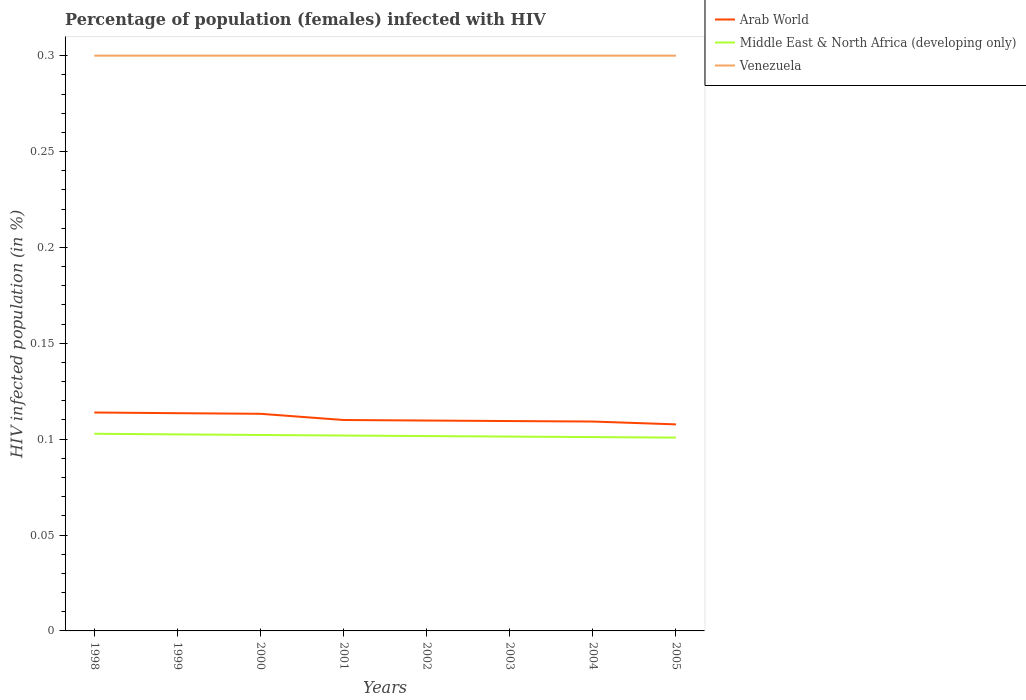How many different coloured lines are there?
Provide a succinct answer. 3. Does the line corresponding to Venezuela intersect with the line corresponding to Arab World?
Ensure brevity in your answer.  No. Across all years, what is the maximum percentage of HIV infected female population in Arab World?
Provide a succinct answer. 0.11. What is the total percentage of HIV infected female population in Arab World in the graph?
Your response must be concise. 0. What is the difference between the highest and the second highest percentage of HIV infected female population in Middle East & North Africa (developing only)?
Your answer should be very brief. 0. Is the percentage of HIV infected female population in Venezuela strictly greater than the percentage of HIV infected female population in Arab World over the years?
Offer a very short reply. No. How many years are there in the graph?
Give a very brief answer. 8. Does the graph contain any zero values?
Ensure brevity in your answer.  No. Where does the legend appear in the graph?
Offer a terse response. Top right. How many legend labels are there?
Your answer should be very brief. 3. How are the legend labels stacked?
Keep it short and to the point. Vertical. What is the title of the graph?
Give a very brief answer. Percentage of population (females) infected with HIV. What is the label or title of the Y-axis?
Your response must be concise. HIV infected population (in %). What is the HIV infected population (in %) of Arab World in 1998?
Ensure brevity in your answer.  0.11. What is the HIV infected population (in %) in Middle East & North Africa (developing only) in 1998?
Keep it short and to the point. 0.1. What is the HIV infected population (in %) of Venezuela in 1998?
Ensure brevity in your answer.  0.3. What is the HIV infected population (in %) in Arab World in 1999?
Your answer should be compact. 0.11. What is the HIV infected population (in %) in Middle East & North Africa (developing only) in 1999?
Your answer should be very brief. 0.1. What is the HIV infected population (in %) of Arab World in 2000?
Your answer should be compact. 0.11. What is the HIV infected population (in %) in Middle East & North Africa (developing only) in 2000?
Ensure brevity in your answer.  0.1. What is the HIV infected population (in %) of Venezuela in 2000?
Provide a succinct answer. 0.3. What is the HIV infected population (in %) of Arab World in 2001?
Your answer should be compact. 0.11. What is the HIV infected population (in %) in Middle East & North Africa (developing only) in 2001?
Offer a terse response. 0.1. What is the HIV infected population (in %) in Venezuela in 2001?
Give a very brief answer. 0.3. What is the HIV infected population (in %) of Arab World in 2002?
Ensure brevity in your answer.  0.11. What is the HIV infected population (in %) of Middle East & North Africa (developing only) in 2002?
Offer a very short reply. 0.1. What is the HIV infected population (in %) in Arab World in 2003?
Make the answer very short. 0.11. What is the HIV infected population (in %) in Middle East & North Africa (developing only) in 2003?
Make the answer very short. 0.1. What is the HIV infected population (in %) in Venezuela in 2003?
Your response must be concise. 0.3. What is the HIV infected population (in %) of Arab World in 2004?
Provide a short and direct response. 0.11. What is the HIV infected population (in %) of Middle East & North Africa (developing only) in 2004?
Offer a terse response. 0.1. What is the HIV infected population (in %) in Arab World in 2005?
Provide a short and direct response. 0.11. What is the HIV infected population (in %) of Middle East & North Africa (developing only) in 2005?
Offer a terse response. 0.1. Across all years, what is the maximum HIV infected population (in %) of Arab World?
Offer a terse response. 0.11. Across all years, what is the maximum HIV infected population (in %) in Middle East & North Africa (developing only)?
Your answer should be very brief. 0.1. Across all years, what is the maximum HIV infected population (in %) in Venezuela?
Keep it short and to the point. 0.3. Across all years, what is the minimum HIV infected population (in %) in Arab World?
Provide a short and direct response. 0.11. Across all years, what is the minimum HIV infected population (in %) in Middle East & North Africa (developing only)?
Your answer should be compact. 0.1. What is the total HIV infected population (in %) of Arab World in the graph?
Your answer should be very brief. 0.89. What is the total HIV infected population (in %) of Middle East & North Africa (developing only) in the graph?
Your answer should be very brief. 0.81. What is the difference between the HIV infected population (in %) of Middle East & North Africa (developing only) in 1998 and that in 1999?
Your response must be concise. 0. What is the difference between the HIV infected population (in %) in Venezuela in 1998 and that in 1999?
Offer a very short reply. 0. What is the difference between the HIV infected population (in %) of Arab World in 1998 and that in 2000?
Offer a terse response. 0. What is the difference between the HIV infected population (in %) of Middle East & North Africa (developing only) in 1998 and that in 2000?
Ensure brevity in your answer.  0. What is the difference between the HIV infected population (in %) of Venezuela in 1998 and that in 2000?
Your answer should be very brief. 0. What is the difference between the HIV infected population (in %) of Arab World in 1998 and that in 2001?
Offer a terse response. 0. What is the difference between the HIV infected population (in %) of Middle East & North Africa (developing only) in 1998 and that in 2001?
Ensure brevity in your answer.  0. What is the difference between the HIV infected population (in %) of Venezuela in 1998 and that in 2001?
Your response must be concise. 0. What is the difference between the HIV infected population (in %) in Arab World in 1998 and that in 2002?
Your response must be concise. 0. What is the difference between the HIV infected population (in %) of Middle East & North Africa (developing only) in 1998 and that in 2002?
Give a very brief answer. 0. What is the difference between the HIV infected population (in %) in Arab World in 1998 and that in 2003?
Your response must be concise. 0. What is the difference between the HIV infected population (in %) in Middle East & North Africa (developing only) in 1998 and that in 2003?
Offer a very short reply. 0. What is the difference between the HIV infected population (in %) in Arab World in 1998 and that in 2004?
Provide a short and direct response. 0. What is the difference between the HIV infected population (in %) of Middle East & North Africa (developing only) in 1998 and that in 2004?
Your answer should be very brief. 0. What is the difference between the HIV infected population (in %) in Venezuela in 1998 and that in 2004?
Provide a succinct answer. 0. What is the difference between the HIV infected population (in %) in Arab World in 1998 and that in 2005?
Provide a succinct answer. 0.01. What is the difference between the HIV infected population (in %) of Middle East & North Africa (developing only) in 1998 and that in 2005?
Your answer should be very brief. 0. What is the difference between the HIV infected population (in %) in Arab World in 1999 and that in 2000?
Make the answer very short. 0. What is the difference between the HIV infected population (in %) of Middle East & North Africa (developing only) in 1999 and that in 2000?
Offer a terse response. 0. What is the difference between the HIV infected population (in %) in Arab World in 1999 and that in 2001?
Offer a terse response. 0. What is the difference between the HIV infected population (in %) of Middle East & North Africa (developing only) in 1999 and that in 2001?
Your answer should be compact. 0. What is the difference between the HIV infected population (in %) of Arab World in 1999 and that in 2002?
Offer a terse response. 0. What is the difference between the HIV infected population (in %) of Middle East & North Africa (developing only) in 1999 and that in 2002?
Keep it short and to the point. 0. What is the difference between the HIV infected population (in %) of Arab World in 1999 and that in 2003?
Provide a short and direct response. 0. What is the difference between the HIV infected population (in %) in Middle East & North Africa (developing only) in 1999 and that in 2003?
Provide a short and direct response. 0. What is the difference between the HIV infected population (in %) of Venezuela in 1999 and that in 2003?
Your response must be concise. 0. What is the difference between the HIV infected population (in %) in Arab World in 1999 and that in 2004?
Give a very brief answer. 0. What is the difference between the HIV infected population (in %) of Middle East & North Africa (developing only) in 1999 and that in 2004?
Ensure brevity in your answer.  0. What is the difference between the HIV infected population (in %) in Venezuela in 1999 and that in 2004?
Ensure brevity in your answer.  0. What is the difference between the HIV infected population (in %) in Arab World in 1999 and that in 2005?
Your answer should be compact. 0.01. What is the difference between the HIV infected population (in %) of Middle East & North Africa (developing only) in 1999 and that in 2005?
Make the answer very short. 0. What is the difference between the HIV infected population (in %) of Venezuela in 1999 and that in 2005?
Your answer should be very brief. 0. What is the difference between the HIV infected population (in %) in Arab World in 2000 and that in 2001?
Make the answer very short. 0. What is the difference between the HIV infected population (in %) of Middle East & North Africa (developing only) in 2000 and that in 2001?
Provide a short and direct response. 0. What is the difference between the HIV infected population (in %) in Venezuela in 2000 and that in 2001?
Ensure brevity in your answer.  0. What is the difference between the HIV infected population (in %) in Arab World in 2000 and that in 2002?
Give a very brief answer. 0. What is the difference between the HIV infected population (in %) in Middle East & North Africa (developing only) in 2000 and that in 2002?
Offer a very short reply. 0. What is the difference between the HIV infected population (in %) in Venezuela in 2000 and that in 2002?
Your response must be concise. 0. What is the difference between the HIV infected population (in %) of Arab World in 2000 and that in 2003?
Give a very brief answer. 0. What is the difference between the HIV infected population (in %) in Middle East & North Africa (developing only) in 2000 and that in 2003?
Offer a very short reply. 0. What is the difference between the HIV infected population (in %) in Venezuela in 2000 and that in 2003?
Offer a very short reply. 0. What is the difference between the HIV infected population (in %) in Arab World in 2000 and that in 2004?
Your answer should be very brief. 0. What is the difference between the HIV infected population (in %) of Middle East & North Africa (developing only) in 2000 and that in 2004?
Offer a terse response. 0. What is the difference between the HIV infected population (in %) in Venezuela in 2000 and that in 2004?
Offer a very short reply. 0. What is the difference between the HIV infected population (in %) in Arab World in 2000 and that in 2005?
Your response must be concise. 0.01. What is the difference between the HIV infected population (in %) of Middle East & North Africa (developing only) in 2000 and that in 2005?
Keep it short and to the point. 0. What is the difference between the HIV infected population (in %) of Venezuela in 2000 and that in 2005?
Offer a very short reply. 0. What is the difference between the HIV infected population (in %) in Arab World in 2001 and that in 2002?
Provide a succinct answer. 0. What is the difference between the HIV infected population (in %) of Arab World in 2001 and that in 2004?
Give a very brief answer. 0. What is the difference between the HIV infected population (in %) in Middle East & North Africa (developing only) in 2001 and that in 2004?
Keep it short and to the point. 0. What is the difference between the HIV infected population (in %) in Arab World in 2001 and that in 2005?
Offer a very short reply. 0. What is the difference between the HIV infected population (in %) in Middle East & North Africa (developing only) in 2001 and that in 2005?
Make the answer very short. 0. What is the difference between the HIV infected population (in %) in Arab World in 2002 and that in 2003?
Provide a succinct answer. 0. What is the difference between the HIV infected population (in %) of Venezuela in 2002 and that in 2003?
Your answer should be compact. 0. What is the difference between the HIV infected population (in %) in Arab World in 2002 and that in 2004?
Your answer should be compact. 0. What is the difference between the HIV infected population (in %) of Arab World in 2002 and that in 2005?
Offer a terse response. 0. What is the difference between the HIV infected population (in %) in Middle East & North Africa (developing only) in 2002 and that in 2005?
Provide a short and direct response. 0. What is the difference between the HIV infected population (in %) in Arab World in 2003 and that in 2004?
Offer a very short reply. 0. What is the difference between the HIV infected population (in %) in Middle East & North Africa (developing only) in 2003 and that in 2004?
Keep it short and to the point. 0. What is the difference between the HIV infected population (in %) in Arab World in 2003 and that in 2005?
Keep it short and to the point. 0. What is the difference between the HIV infected population (in %) of Middle East & North Africa (developing only) in 2003 and that in 2005?
Your answer should be very brief. 0. What is the difference between the HIV infected population (in %) of Venezuela in 2003 and that in 2005?
Your answer should be very brief. 0. What is the difference between the HIV infected population (in %) in Arab World in 2004 and that in 2005?
Offer a terse response. 0. What is the difference between the HIV infected population (in %) in Venezuela in 2004 and that in 2005?
Your response must be concise. 0. What is the difference between the HIV infected population (in %) in Arab World in 1998 and the HIV infected population (in %) in Middle East & North Africa (developing only) in 1999?
Ensure brevity in your answer.  0.01. What is the difference between the HIV infected population (in %) of Arab World in 1998 and the HIV infected population (in %) of Venezuela in 1999?
Your answer should be very brief. -0.19. What is the difference between the HIV infected population (in %) of Middle East & North Africa (developing only) in 1998 and the HIV infected population (in %) of Venezuela in 1999?
Your answer should be compact. -0.2. What is the difference between the HIV infected population (in %) in Arab World in 1998 and the HIV infected population (in %) in Middle East & North Africa (developing only) in 2000?
Give a very brief answer. 0.01. What is the difference between the HIV infected population (in %) in Arab World in 1998 and the HIV infected population (in %) in Venezuela in 2000?
Provide a short and direct response. -0.19. What is the difference between the HIV infected population (in %) in Middle East & North Africa (developing only) in 1998 and the HIV infected population (in %) in Venezuela in 2000?
Provide a succinct answer. -0.2. What is the difference between the HIV infected population (in %) of Arab World in 1998 and the HIV infected population (in %) of Middle East & North Africa (developing only) in 2001?
Your answer should be very brief. 0.01. What is the difference between the HIV infected population (in %) in Arab World in 1998 and the HIV infected population (in %) in Venezuela in 2001?
Make the answer very short. -0.19. What is the difference between the HIV infected population (in %) in Middle East & North Africa (developing only) in 1998 and the HIV infected population (in %) in Venezuela in 2001?
Offer a terse response. -0.2. What is the difference between the HIV infected population (in %) of Arab World in 1998 and the HIV infected population (in %) of Middle East & North Africa (developing only) in 2002?
Keep it short and to the point. 0.01. What is the difference between the HIV infected population (in %) of Arab World in 1998 and the HIV infected population (in %) of Venezuela in 2002?
Offer a terse response. -0.19. What is the difference between the HIV infected population (in %) in Middle East & North Africa (developing only) in 1998 and the HIV infected population (in %) in Venezuela in 2002?
Provide a short and direct response. -0.2. What is the difference between the HIV infected population (in %) in Arab World in 1998 and the HIV infected population (in %) in Middle East & North Africa (developing only) in 2003?
Provide a succinct answer. 0.01. What is the difference between the HIV infected population (in %) in Arab World in 1998 and the HIV infected population (in %) in Venezuela in 2003?
Your answer should be very brief. -0.19. What is the difference between the HIV infected population (in %) of Middle East & North Africa (developing only) in 1998 and the HIV infected population (in %) of Venezuela in 2003?
Your answer should be compact. -0.2. What is the difference between the HIV infected population (in %) of Arab World in 1998 and the HIV infected population (in %) of Middle East & North Africa (developing only) in 2004?
Make the answer very short. 0.01. What is the difference between the HIV infected population (in %) of Arab World in 1998 and the HIV infected population (in %) of Venezuela in 2004?
Your answer should be compact. -0.19. What is the difference between the HIV infected population (in %) in Middle East & North Africa (developing only) in 1998 and the HIV infected population (in %) in Venezuela in 2004?
Provide a short and direct response. -0.2. What is the difference between the HIV infected population (in %) in Arab World in 1998 and the HIV infected population (in %) in Middle East & North Africa (developing only) in 2005?
Make the answer very short. 0.01. What is the difference between the HIV infected population (in %) of Arab World in 1998 and the HIV infected population (in %) of Venezuela in 2005?
Give a very brief answer. -0.19. What is the difference between the HIV infected population (in %) of Middle East & North Africa (developing only) in 1998 and the HIV infected population (in %) of Venezuela in 2005?
Ensure brevity in your answer.  -0.2. What is the difference between the HIV infected population (in %) of Arab World in 1999 and the HIV infected population (in %) of Middle East & North Africa (developing only) in 2000?
Your answer should be very brief. 0.01. What is the difference between the HIV infected population (in %) of Arab World in 1999 and the HIV infected population (in %) of Venezuela in 2000?
Your response must be concise. -0.19. What is the difference between the HIV infected population (in %) of Middle East & North Africa (developing only) in 1999 and the HIV infected population (in %) of Venezuela in 2000?
Your response must be concise. -0.2. What is the difference between the HIV infected population (in %) in Arab World in 1999 and the HIV infected population (in %) in Middle East & North Africa (developing only) in 2001?
Give a very brief answer. 0.01. What is the difference between the HIV infected population (in %) in Arab World in 1999 and the HIV infected population (in %) in Venezuela in 2001?
Your answer should be very brief. -0.19. What is the difference between the HIV infected population (in %) in Middle East & North Africa (developing only) in 1999 and the HIV infected population (in %) in Venezuela in 2001?
Ensure brevity in your answer.  -0.2. What is the difference between the HIV infected population (in %) in Arab World in 1999 and the HIV infected population (in %) in Middle East & North Africa (developing only) in 2002?
Your response must be concise. 0.01. What is the difference between the HIV infected population (in %) in Arab World in 1999 and the HIV infected population (in %) in Venezuela in 2002?
Your answer should be very brief. -0.19. What is the difference between the HIV infected population (in %) in Middle East & North Africa (developing only) in 1999 and the HIV infected population (in %) in Venezuela in 2002?
Give a very brief answer. -0.2. What is the difference between the HIV infected population (in %) of Arab World in 1999 and the HIV infected population (in %) of Middle East & North Africa (developing only) in 2003?
Your response must be concise. 0.01. What is the difference between the HIV infected population (in %) in Arab World in 1999 and the HIV infected population (in %) in Venezuela in 2003?
Provide a short and direct response. -0.19. What is the difference between the HIV infected population (in %) of Middle East & North Africa (developing only) in 1999 and the HIV infected population (in %) of Venezuela in 2003?
Your answer should be compact. -0.2. What is the difference between the HIV infected population (in %) in Arab World in 1999 and the HIV infected population (in %) in Middle East & North Africa (developing only) in 2004?
Your answer should be very brief. 0.01. What is the difference between the HIV infected population (in %) in Arab World in 1999 and the HIV infected population (in %) in Venezuela in 2004?
Provide a succinct answer. -0.19. What is the difference between the HIV infected population (in %) in Middle East & North Africa (developing only) in 1999 and the HIV infected population (in %) in Venezuela in 2004?
Give a very brief answer. -0.2. What is the difference between the HIV infected population (in %) in Arab World in 1999 and the HIV infected population (in %) in Middle East & North Africa (developing only) in 2005?
Provide a short and direct response. 0.01. What is the difference between the HIV infected population (in %) of Arab World in 1999 and the HIV infected population (in %) of Venezuela in 2005?
Provide a succinct answer. -0.19. What is the difference between the HIV infected population (in %) in Middle East & North Africa (developing only) in 1999 and the HIV infected population (in %) in Venezuela in 2005?
Ensure brevity in your answer.  -0.2. What is the difference between the HIV infected population (in %) of Arab World in 2000 and the HIV infected population (in %) of Middle East & North Africa (developing only) in 2001?
Your answer should be compact. 0.01. What is the difference between the HIV infected population (in %) of Arab World in 2000 and the HIV infected population (in %) of Venezuela in 2001?
Your answer should be very brief. -0.19. What is the difference between the HIV infected population (in %) in Middle East & North Africa (developing only) in 2000 and the HIV infected population (in %) in Venezuela in 2001?
Offer a terse response. -0.2. What is the difference between the HIV infected population (in %) of Arab World in 2000 and the HIV infected population (in %) of Middle East & North Africa (developing only) in 2002?
Give a very brief answer. 0.01. What is the difference between the HIV infected population (in %) in Arab World in 2000 and the HIV infected population (in %) in Venezuela in 2002?
Keep it short and to the point. -0.19. What is the difference between the HIV infected population (in %) in Middle East & North Africa (developing only) in 2000 and the HIV infected population (in %) in Venezuela in 2002?
Keep it short and to the point. -0.2. What is the difference between the HIV infected population (in %) of Arab World in 2000 and the HIV infected population (in %) of Middle East & North Africa (developing only) in 2003?
Keep it short and to the point. 0.01. What is the difference between the HIV infected population (in %) in Arab World in 2000 and the HIV infected population (in %) in Venezuela in 2003?
Offer a terse response. -0.19. What is the difference between the HIV infected population (in %) of Middle East & North Africa (developing only) in 2000 and the HIV infected population (in %) of Venezuela in 2003?
Provide a short and direct response. -0.2. What is the difference between the HIV infected population (in %) in Arab World in 2000 and the HIV infected population (in %) in Middle East & North Africa (developing only) in 2004?
Make the answer very short. 0.01. What is the difference between the HIV infected population (in %) of Arab World in 2000 and the HIV infected population (in %) of Venezuela in 2004?
Your response must be concise. -0.19. What is the difference between the HIV infected population (in %) of Middle East & North Africa (developing only) in 2000 and the HIV infected population (in %) of Venezuela in 2004?
Your response must be concise. -0.2. What is the difference between the HIV infected population (in %) of Arab World in 2000 and the HIV infected population (in %) of Middle East & North Africa (developing only) in 2005?
Keep it short and to the point. 0.01. What is the difference between the HIV infected population (in %) in Arab World in 2000 and the HIV infected population (in %) in Venezuela in 2005?
Keep it short and to the point. -0.19. What is the difference between the HIV infected population (in %) of Middle East & North Africa (developing only) in 2000 and the HIV infected population (in %) of Venezuela in 2005?
Give a very brief answer. -0.2. What is the difference between the HIV infected population (in %) of Arab World in 2001 and the HIV infected population (in %) of Middle East & North Africa (developing only) in 2002?
Make the answer very short. 0.01. What is the difference between the HIV infected population (in %) in Arab World in 2001 and the HIV infected population (in %) in Venezuela in 2002?
Ensure brevity in your answer.  -0.19. What is the difference between the HIV infected population (in %) in Middle East & North Africa (developing only) in 2001 and the HIV infected population (in %) in Venezuela in 2002?
Your answer should be compact. -0.2. What is the difference between the HIV infected population (in %) of Arab World in 2001 and the HIV infected population (in %) of Middle East & North Africa (developing only) in 2003?
Offer a very short reply. 0.01. What is the difference between the HIV infected population (in %) in Arab World in 2001 and the HIV infected population (in %) in Venezuela in 2003?
Your answer should be compact. -0.19. What is the difference between the HIV infected population (in %) in Middle East & North Africa (developing only) in 2001 and the HIV infected population (in %) in Venezuela in 2003?
Offer a terse response. -0.2. What is the difference between the HIV infected population (in %) of Arab World in 2001 and the HIV infected population (in %) of Middle East & North Africa (developing only) in 2004?
Offer a very short reply. 0.01. What is the difference between the HIV infected population (in %) of Arab World in 2001 and the HIV infected population (in %) of Venezuela in 2004?
Give a very brief answer. -0.19. What is the difference between the HIV infected population (in %) of Middle East & North Africa (developing only) in 2001 and the HIV infected population (in %) of Venezuela in 2004?
Offer a very short reply. -0.2. What is the difference between the HIV infected population (in %) in Arab World in 2001 and the HIV infected population (in %) in Middle East & North Africa (developing only) in 2005?
Make the answer very short. 0.01. What is the difference between the HIV infected population (in %) in Arab World in 2001 and the HIV infected population (in %) in Venezuela in 2005?
Provide a succinct answer. -0.19. What is the difference between the HIV infected population (in %) of Middle East & North Africa (developing only) in 2001 and the HIV infected population (in %) of Venezuela in 2005?
Give a very brief answer. -0.2. What is the difference between the HIV infected population (in %) of Arab World in 2002 and the HIV infected population (in %) of Middle East & North Africa (developing only) in 2003?
Provide a short and direct response. 0.01. What is the difference between the HIV infected population (in %) in Arab World in 2002 and the HIV infected population (in %) in Venezuela in 2003?
Make the answer very short. -0.19. What is the difference between the HIV infected population (in %) of Middle East & North Africa (developing only) in 2002 and the HIV infected population (in %) of Venezuela in 2003?
Your answer should be very brief. -0.2. What is the difference between the HIV infected population (in %) of Arab World in 2002 and the HIV infected population (in %) of Middle East & North Africa (developing only) in 2004?
Offer a very short reply. 0.01. What is the difference between the HIV infected population (in %) of Arab World in 2002 and the HIV infected population (in %) of Venezuela in 2004?
Keep it short and to the point. -0.19. What is the difference between the HIV infected population (in %) of Middle East & North Africa (developing only) in 2002 and the HIV infected population (in %) of Venezuela in 2004?
Your answer should be very brief. -0.2. What is the difference between the HIV infected population (in %) of Arab World in 2002 and the HIV infected population (in %) of Middle East & North Africa (developing only) in 2005?
Your answer should be very brief. 0.01. What is the difference between the HIV infected population (in %) of Arab World in 2002 and the HIV infected population (in %) of Venezuela in 2005?
Provide a succinct answer. -0.19. What is the difference between the HIV infected population (in %) in Middle East & North Africa (developing only) in 2002 and the HIV infected population (in %) in Venezuela in 2005?
Your answer should be compact. -0.2. What is the difference between the HIV infected population (in %) of Arab World in 2003 and the HIV infected population (in %) of Middle East & North Africa (developing only) in 2004?
Make the answer very short. 0.01. What is the difference between the HIV infected population (in %) of Arab World in 2003 and the HIV infected population (in %) of Venezuela in 2004?
Your answer should be compact. -0.19. What is the difference between the HIV infected population (in %) in Middle East & North Africa (developing only) in 2003 and the HIV infected population (in %) in Venezuela in 2004?
Offer a terse response. -0.2. What is the difference between the HIV infected population (in %) of Arab World in 2003 and the HIV infected population (in %) of Middle East & North Africa (developing only) in 2005?
Your response must be concise. 0.01. What is the difference between the HIV infected population (in %) in Arab World in 2003 and the HIV infected population (in %) in Venezuela in 2005?
Keep it short and to the point. -0.19. What is the difference between the HIV infected population (in %) in Middle East & North Africa (developing only) in 2003 and the HIV infected population (in %) in Venezuela in 2005?
Your answer should be very brief. -0.2. What is the difference between the HIV infected population (in %) of Arab World in 2004 and the HIV infected population (in %) of Middle East & North Africa (developing only) in 2005?
Provide a short and direct response. 0.01. What is the difference between the HIV infected population (in %) of Arab World in 2004 and the HIV infected population (in %) of Venezuela in 2005?
Ensure brevity in your answer.  -0.19. What is the difference between the HIV infected population (in %) of Middle East & North Africa (developing only) in 2004 and the HIV infected population (in %) of Venezuela in 2005?
Your answer should be compact. -0.2. What is the average HIV infected population (in %) of Arab World per year?
Your response must be concise. 0.11. What is the average HIV infected population (in %) in Middle East & North Africa (developing only) per year?
Provide a short and direct response. 0.1. In the year 1998, what is the difference between the HIV infected population (in %) in Arab World and HIV infected population (in %) in Middle East & North Africa (developing only)?
Keep it short and to the point. 0.01. In the year 1998, what is the difference between the HIV infected population (in %) of Arab World and HIV infected population (in %) of Venezuela?
Offer a terse response. -0.19. In the year 1998, what is the difference between the HIV infected population (in %) in Middle East & North Africa (developing only) and HIV infected population (in %) in Venezuela?
Your response must be concise. -0.2. In the year 1999, what is the difference between the HIV infected population (in %) in Arab World and HIV infected population (in %) in Middle East & North Africa (developing only)?
Provide a short and direct response. 0.01. In the year 1999, what is the difference between the HIV infected population (in %) of Arab World and HIV infected population (in %) of Venezuela?
Offer a terse response. -0.19. In the year 1999, what is the difference between the HIV infected population (in %) in Middle East & North Africa (developing only) and HIV infected population (in %) in Venezuela?
Keep it short and to the point. -0.2. In the year 2000, what is the difference between the HIV infected population (in %) in Arab World and HIV infected population (in %) in Middle East & North Africa (developing only)?
Your answer should be compact. 0.01. In the year 2000, what is the difference between the HIV infected population (in %) of Arab World and HIV infected population (in %) of Venezuela?
Your response must be concise. -0.19. In the year 2000, what is the difference between the HIV infected population (in %) in Middle East & North Africa (developing only) and HIV infected population (in %) in Venezuela?
Your answer should be very brief. -0.2. In the year 2001, what is the difference between the HIV infected population (in %) in Arab World and HIV infected population (in %) in Middle East & North Africa (developing only)?
Ensure brevity in your answer.  0.01. In the year 2001, what is the difference between the HIV infected population (in %) in Arab World and HIV infected population (in %) in Venezuela?
Make the answer very short. -0.19. In the year 2001, what is the difference between the HIV infected population (in %) of Middle East & North Africa (developing only) and HIV infected population (in %) of Venezuela?
Ensure brevity in your answer.  -0.2. In the year 2002, what is the difference between the HIV infected population (in %) in Arab World and HIV infected population (in %) in Middle East & North Africa (developing only)?
Ensure brevity in your answer.  0.01. In the year 2002, what is the difference between the HIV infected population (in %) in Arab World and HIV infected population (in %) in Venezuela?
Provide a short and direct response. -0.19. In the year 2002, what is the difference between the HIV infected population (in %) in Middle East & North Africa (developing only) and HIV infected population (in %) in Venezuela?
Offer a very short reply. -0.2. In the year 2003, what is the difference between the HIV infected population (in %) of Arab World and HIV infected population (in %) of Middle East & North Africa (developing only)?
Ensure brevity in your answer.  0.01. In the year 2003, what is the difference between the HIV infected population (in %) of Arab World and HIV infected population (in %) of Venezuela?
Your answer should be very brief. -0.19. In the year 2003, what is the difference between the HIV infected population (in %) of Middle East & North Africa (developing only) and HIV infected population (in %) of Venezuela?
Your answer should be compact. -0.2. In the year 2004, what is the difference between the HIV infected population (in %) in Arab World and HIV infected population (in %) in Middle East & North Africa (developing only)?
Your response must be concise. 0.01. In the year 2004, what is the difference between the HIV infected population (in %) in Arab World and HIV infected population (in %) in Venezuela?
Provide a short and direct response. -0.19. In the year 2004, what is the difference between the HIV infected population (in %) of Middle East & North Africa (developing only) and HIV infected population (in %) of Venezuela?
Ensure brevity in your answer.  -0.2. In the year 2005, what is the difference between the HIV infected population (in %) in Arab World and HIV infected population (in %) in Middle East & North Africa (developing only)?
Give a very brief answer. 0.01. In the year 2005, what is the difference between the HIV infected population (in %) in Arab World and HIV infected population (in %) in Venezuela?
Your answer should be compact. -0.19. In the year 2005, what is the difference between the HIV infected population (in %) of Middle East & North Africa (developing only) and HIV infected population (in %) of Venezuela?
Provide a succinct answer. -0.2. What is the ratio of the HIV infected population (in %) of Arab World in 1998 to that in 1999?
Offer a terse response. 1. What is the ratio of the HIV infected population (in %) of Middle East & North Africa (developing only) in 1998 to that in 1999?
Make the answer very short. 1. What is the ratio of the HIV infected population (in %) of Venezuela in 1998 to that in 1999?
Provide a succinct answer. 1. What is the ratio of the HIV infected population (in %) in Arab World in 1998 to that in 2000?
Give a very brief answer. 1.01. What is the ratio of the HIV infected population (in %) in Middle East & North Africa (developing only) in 1998 to that in 2000?
Offer a terse response. 1.01. What is the ratio of the HIV infected population (in %) in Arab World in 1998 to that in 2001?
Make the answer very short. 1.04. What is the ratio of the HIV infected population (in %) in Middle East & North Africa (developing only) in 1998 to that in 2001?
Your response must be concise. 1.01. What is the ratio of the HIV infected population (in %) in Venezuela in 1998 to that in 2001?
Your answer should be very brief. 1. What is the ratio of the HIV infected population (in %) in Arab World in 1998 to that in 2002?
Keep it short and to the point. 1.04. What is the ratio of the HIV infected population (in %) in Middle East & North Africa (developing only) in 1998 to that in 2002?
Your answer should be very brief. 1.01. What is the ratio of the HIV infected population (in %) in Venezuela in 1998 to that in 2002?
Keep it short and to the point. 1. What is the ratio of the HIV infected population (in %) of Arab World in 1998 to that in 2003?
Keep it short and to the point. 1.04. What is the ratio of the HIV infected population (in %) in Middle East & North Africa (developing only) in 1998 to that in 2003?
Give a very brief answer. 1.01. What is the ratio of the HIV infected population (in %) of Venezuela in 1998 to that in 2003?
Your response must be concise. 1. What is the ratio of the HIV infected population (in %) of Arab World in 1998 to that in 2004?
Make the answer very short. 1.04. What is the ratio of the HIV infected population (in %) of Middle East & North Africa (developing only) in 1998 to that in 2004?
Keep it short and to the point. 1.02. What is the ratio of the HIV infected population (in %) in Arab World in 1998 to that in 2005?
Keep it short and to the point. 1.06. What is the ratio of the HIV infected population (in %) in Middle East & North Africa (developing only) in 1998 to that in 2005?
Your answer should be compact. 1.02. What is the ratio of the HIV infected population (in %) in Venezuela in 1998 to that in 2005?
Keep it short and to the point. 1. What is the ratio of the HIV infected population (in %) in Arab World in 1999 to that in 2000?
Keep it short and to the point. 1. What is the ratio of the HIV infected population (in %) of Arab World in 1999 to that in 2001?
Your answer should be very brief. 1.03. What is the ratio of the HIV infected population (in %) of Middle East & North Africa (developing only) in 1999 to that in 2001?
Give a very brief answer. 1.01. What is the ratio of the HIV infected population (in %) of Arab World in 1999 to that in 2002?
Provide a succinct answer. 1.03. What is the ratio of the HIV infected population (in %) of Middle East & North Africa (developing only) in 1999 to that in 2002?
Your answer should be very brief. 1.01. What is the ratio of the HIV infected population (in %) of Arab World in 1999 to that in 2003?
Your answer should be very brief. 1.04. What is the ratio of the HIV infected population (in %) in Middle East & North Africa (developing only) in 1999 to that in 2003?
Your answer should be compact. 1.01. What is the ratio of the HIV infected population (in %) of Venezuela in 1999 to that in 2003?
Your answer should be compact. 1. What is the ratio of the HIV infected population (in %) in Arab World in 1999 to that in 2004?
Your answer should be compact. 1.04. What is the ratio of the HIV infected population (in %) in Middle East & North Africa (developing only) in 1999 to that in 2004?
Your answer should be compact. 1.01. What is the ratio of the HIV infected population (in %) in Arab World in 1999 to that in 2005?
Provide a short and direct response. 1.05. What is the ratio of the HIV infected population (in %) of Middle East & North Africa (developing only) in 1999 to that in 2005?
Your answer should be compact. 1.02. What is the ratio of the HIV infected population (in %) of Arab World in 2000 to that in 2001?
Provide a succinct answer. 1.03. What is the ratio of the HIV infected population (in %) in Middle East & North Africa (developing only) in 2000 to that in 2001?
Your answer should be compact. 1. What is the ratio of the HIV infected population (in %) in Venezuela in 2000 to that in 2001?
Offer a terse response. 1. What is the ratio of the HIV infected population (in %) of Arab World in 2000 to that in 2002?
Offer a terse response. 1.03. What is the ratio of the HIV infected population (in %) in Middle East & North Africa (developing only) in 2000 to that in 2002?
Make the answer very short. 1.01. What is the ratio of the HIV infected population (in %) of Arab World in 2000 to that in 2003?
Your response must be concise. 1.03. What is the ratio of the HIV infected population (in %) of Middle East & North Africa (developing only) in 2000 to that in 2003?
Keep it short and to the point. 1.01. What is the ratio of the HIV infected population (in %) of Arab World in 2000 to that in 2004?
Ensure brevity in your answer.  1.04. What is the ratio of the HIV infected population (in %) in Middle East & North Africa (developing only) in 2000 to that in 2004?
Keep it short and to the point. 1.01. What is the ratio of the HIV infected population (in %) in Venezuela in 2000 to that in 2004?
Your answer should be very brief. 1. What is the ratio of the HIV infected population (in %) in Arab World in 2000 to that in 2005?
Keep it short and to the point. 1.05. What is the ratio of the HIV infected population (in %) in Middle East & North Africa (developing only) in 2000 to that in 2005?
Give a very brief answer. 1.01. What is the ratio of the HIV infected population (in %) in Arab World in 2001 to that in 2003?
Keep it short and to the point. 1. What is the ratio of the HIV infected population (in %) of Middle East & North Africa (developing only) in 2001 to that in 2003?
Your answer should be very brief. 1.01. What is the ratio of the HIV infected population (in %) of Venezuela in 2001 to that in 2003?
Your response must be concise. 1. What is the ratio of the HIV infected population (in %) of Arab World in 2001 to that in 2004?
Offer a very short reply. 1.01. What is the ratio of the HIV infected population (in %) of Middle East & North Africa (developing only) in 2001 to that in 2004?
Make the answer very short. 1.01. What is the ratio of the HIV infected population (in %) of Venezuela in 2001 to that in 2004?
Keep it short and to the point. 1. What is the ratio of the HIV infected population (in %) in Arab World in 2001 to that in 2005?
Ensure brevity in your answer.  1.02. What is the ratio of the HIV infected population (in %) in Middle East & North Africa (developing only) in 2001 to that in 2005?
Make the answer very short. 1.01. What is the ratio of the HIV infected population (in %) in Venezuela in 2001 to that in 2005?
Your answer should be very brief. 1. What is the ratio of the HIV infected population (in %) of Venezuela in 2002 to that in 2004?
Ensure brevity in your answer.  1. What is the ratio of the HIV infected population (in %) in Arab World in 2002 to that in 2005?
Give a very brief answer. 1.02. What is the ratio of the HIV infected population (in %) of Middle East & North Africa (developing only) in 2002 to that in 2005?
Your response must be concise. 1.01. What is the ratio of the HIV infected population (in %) in Venezuela in 2002 to that in 2005?
Ensure brevity in your answer.  1. What is the ratio of the HIV infected population (in %) in Arab World in 2003 to that in 2004?
Your response must be concise. 1. What is the ratio of the HIV infected population (in %) in Venezuela in 2003 to that in 2004?
Your answer should be compact. 1. What is the ratio of the HIV infected population (in %) in Arab World in 2003 to that in 2005?
Your answer should be very brief. 1.02. What is the ratio of the HIV infected population (in %) of Middle East & North Africa (developing only) in 2003 to that in 2005?
Provide a short and direct response. 1.01. What is the ratio of the HIV infected population (in %) in Arab World in 2004 to that in 2005?
Your answer should be compact. 1.01. What is the ratio of the HIV infected population (in %) of Middle East & North Africa (developing only) in 2004 to that in 2005?
Your answer should be compact. 1. What is the difference between the highest and the second highest HIV infected population (in %) in Venezuela?
Keep it short and to the point. 0. What is the difference between the highest and the lowest HIV infected population (in %) of Arab World?
Give a very brief answer. 0.01. What is the difference between the highest and the lowest HIV infected population (in %) of Middle East & North Africa (developing only)?
Provide a short and direct response. 0. 